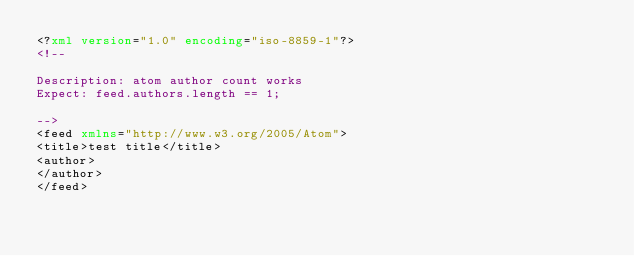Convert code to text. <code><loc_0><loc_0><loc_500><loc_500><_XML_><?xml version="1.0" encoding="iso-8859-1"?>
<!--

Description: atom author count works
Expect: feed.authors.length == 1;

-->
<feed xmlns="http://www.w3.org/2005/Atom">
<title>test title</title>
<author>
</author>
</feed></code> 